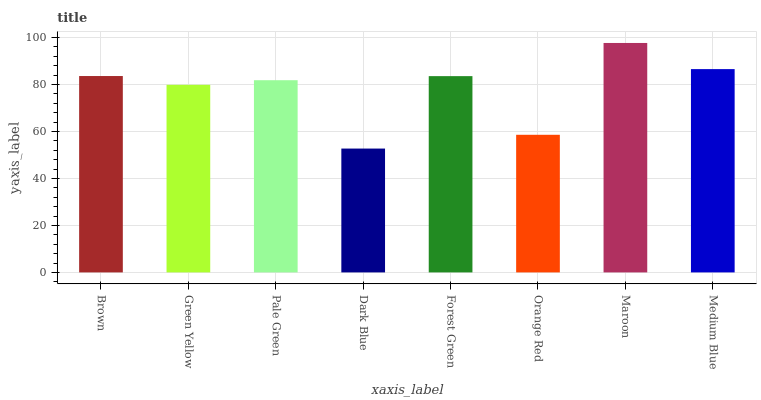Is Dark Blue the minimum?
Answer yes or no. Yes. Is Maroon the maximum?
Answer yes or no. Yes. Is Green Yellow the minimum?
Answer yes or no. No. Is Green Yellow the maximum?
Answer yes or no. No. Is Brown greater than Green Yellow?
Answer yes or no. Yes. Is Green Yellow less than Brown?
Answer yes or no. Yes. Is Green Yellow greater than Brown?
Answer yes or no. No. Is Brown less than Green Yellow?
Answer yes or no. No. Is Forest Green the high median?
Answer yes or no. Yes. Is Pale Green the low median?
Answer yes or no. Yes. Is Medium Blue the high median?
Answer yes or no. No. Is Maroon the low median?
Answer yes or no. No. 